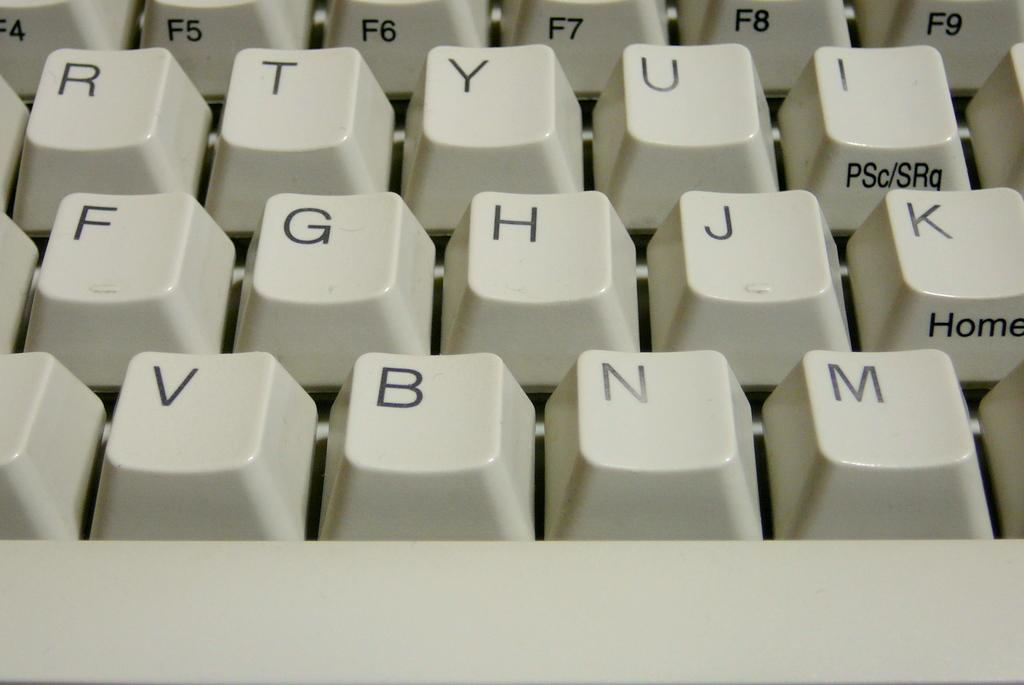<image>
Present a compact description of the photo's key features. A close up of a white keyboard shows the letters V, B, N, and M above the space bar. 